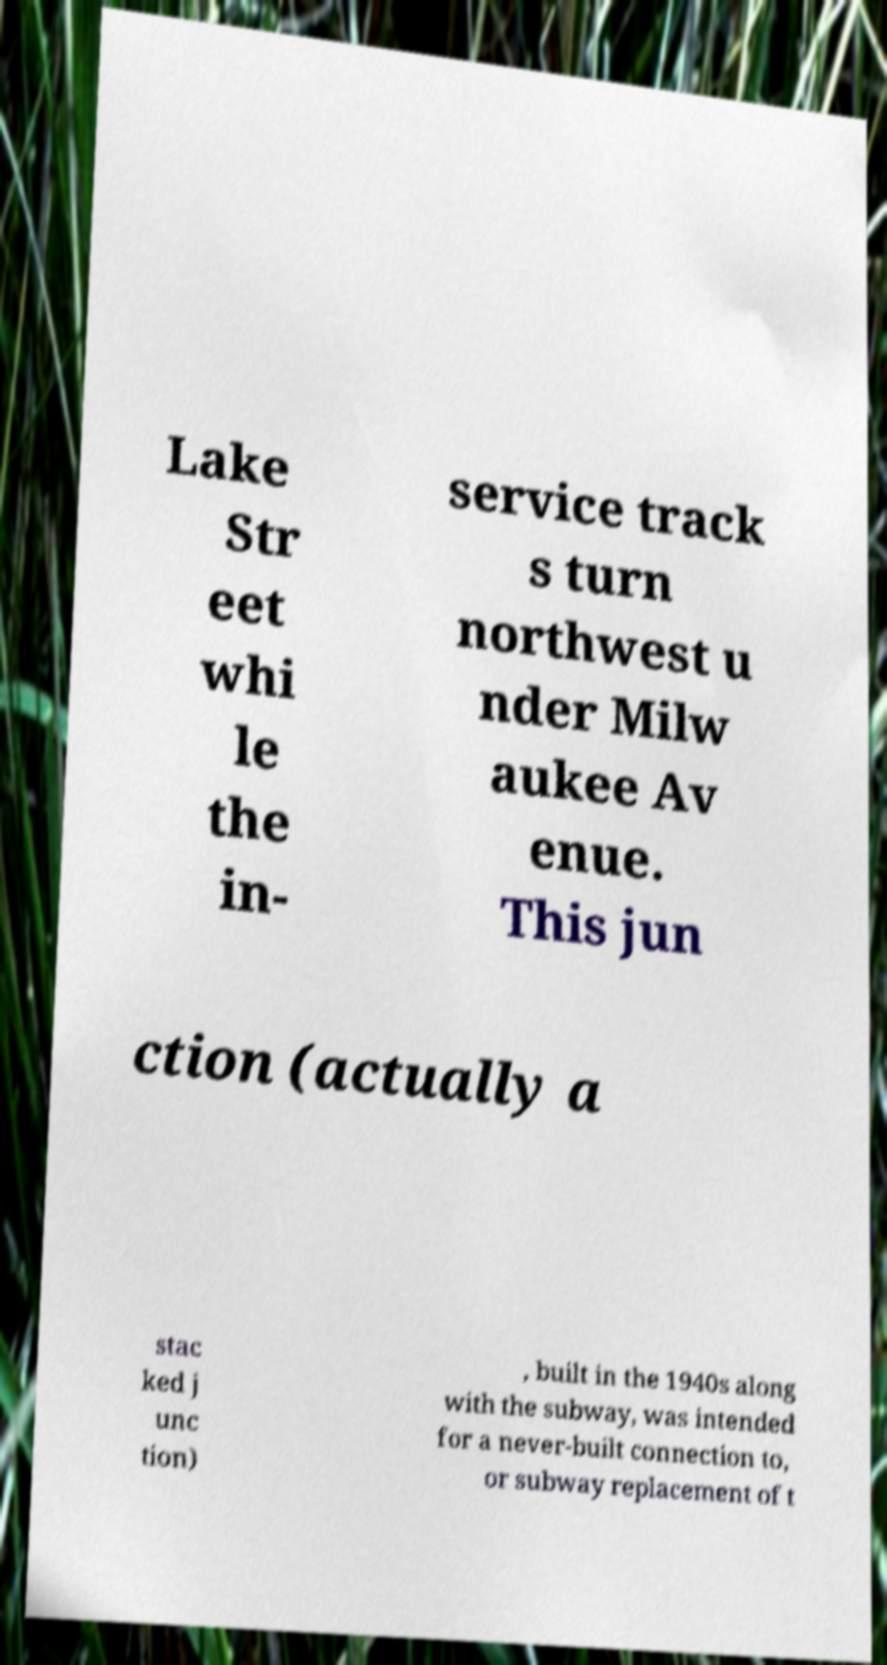There's text embedded in this image that I need extracted. Can you transcribe it verbatim? Lake Str eet whi le the in- service track s turn northwest u nder Milw aukee Av enue. This jun ction (actually a stac ked j unc tion) , built in the 1940s along with the subway, was intended for a never-built connection to, or subway replacement of t 